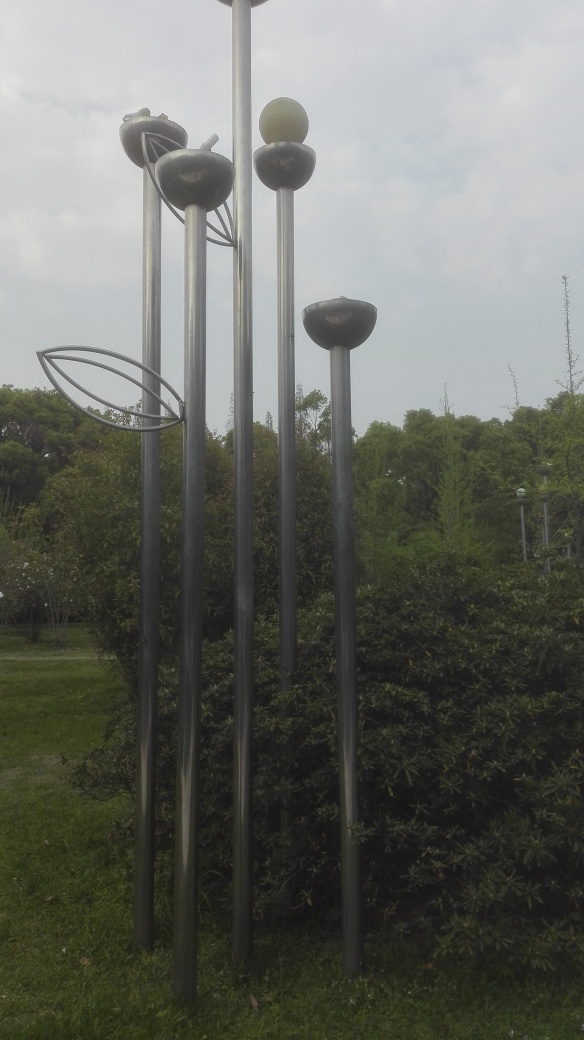Are there any quality issues with this image? The image appears to be in good quality with no immediate visual distortions or pixelation. However, the lighting is slightly dim and the contrast could be improved for better clarity. 